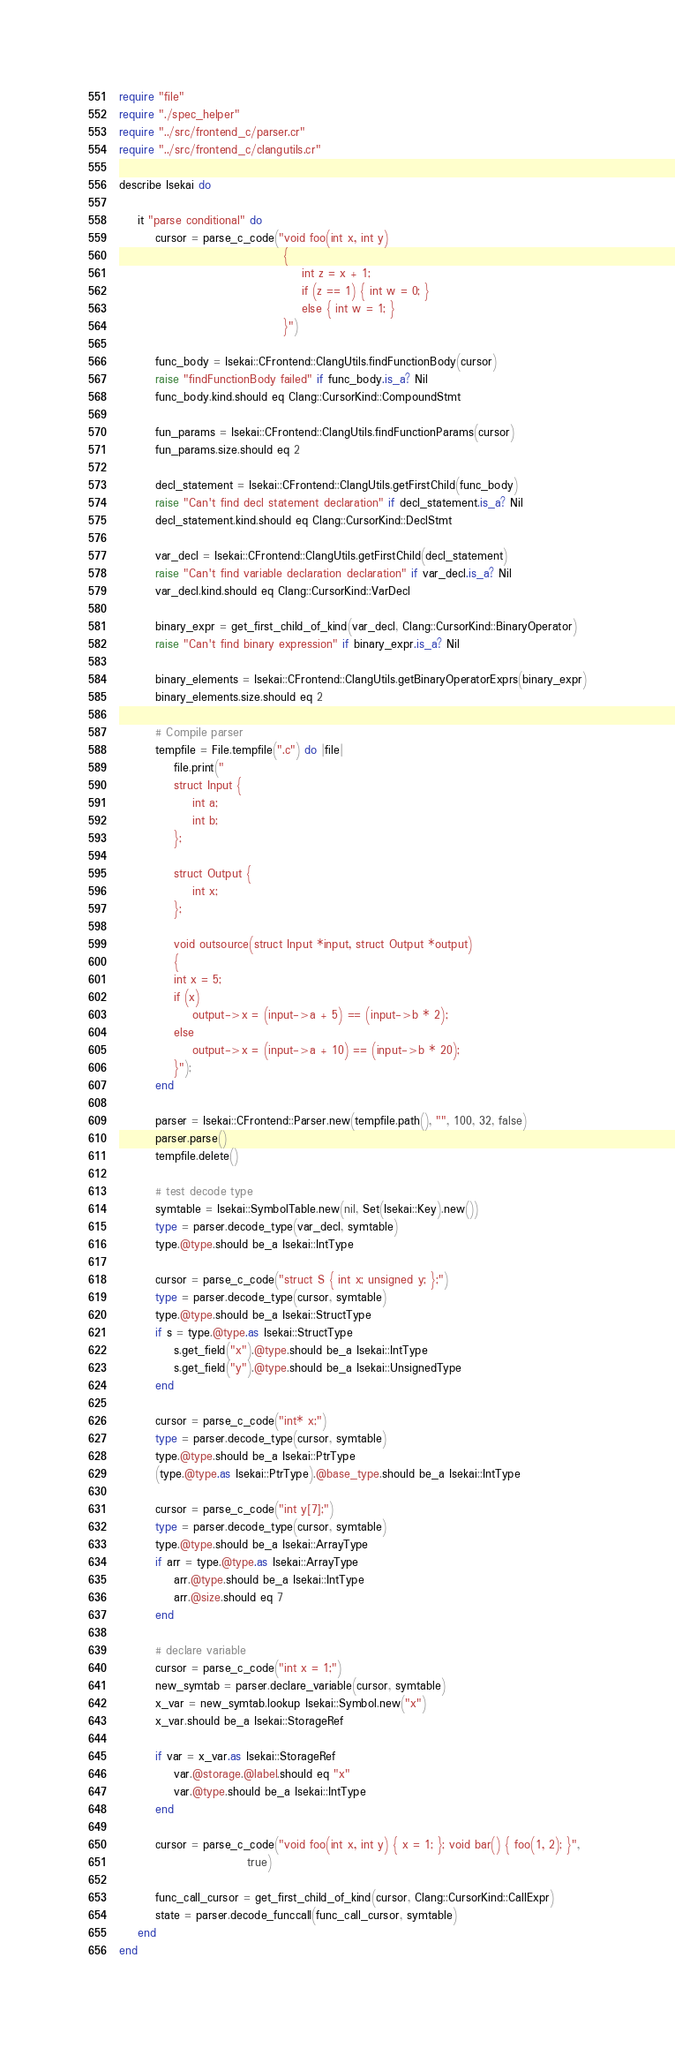Convert code to text. <code><loc_0><loc_0><loc_500><loc_500><_Crystal_>require "file"
require "./spec_helper"
require "../src/frontend_c/parser.cr"
require "../src/frontend_c/clangutils.cr"

describe Isekai do

    it "parse conditional" do
        cursor = parse_c_code("void foo(int x, int y)
                                    { 
                                        int z = x + 1; 
                                        if (z == 1) { int w = 0; }
                                        else { int w = 1; }
                                    }")

        func_body = Isekai::CFrontend::ClangUtils.findFunctionBody(cursor)
        raise "findFunctionBody failed" if func_body.is_a? Nil
        func_body.kind.should eq Clang::CursorKind::CompoundStmt

        fun_params = Isekai::CFrontend::ClangUtils.findFunctionParams(cursor)
        fun_params.size.should eq 2

        decl_statement = Isekai::CFrontend::ClangUtils.getFirstChild(func_body)
        raise "Can't find decl statement declaration" if decl_statement.is_a? Nil
        decl_statement.kind.should eq Clang::CursorKind::DeclStmt

        var_decl = Isekai::CFrontend::ClangUtils.getFirstChild(decl_statement)
        raise "Can't find variable declaration declaration" if var_decl.is_a? Nil
        var_decl.kind.should eq Clang::CursorKind::VarDecl

        binary_expr = get_first_child_of_kind(var_decl, Clang::CursorKind::BinaryOperator)
        raise "Can't find binary expression" if binary_expr.is_a? Nil

        binary_elements = Isekai::CFrontend::ClangUtils.getBinaryOperatorExprs(binary_expr)
        binary_elements.size.should eq 2

        # Compile parser
        tempfile = File.tempfile(".c") do |file|
            file.print("
            struct Input {
                int a;
                int b;
            };

            struct Output {
                int x;
            };

            void outsource(struct Input *input, struct Output *output)
            {
            int x = 5;
            if (x)
                output->x = (input->a + 5) == (input->b * 2);
            else
                output->x = (input->a + 10) == (input->b * 20);
            }");
        end

        parser = Isekai::CFrontend::Parser.new(tempfile.path(), "", 100, 32, false)
        parser.parse()
        tempfile.delete()

        # test decode type
        symtable = Isekai::SymbolTable.new(nil, Set(Isekai::Key).new())
        type = parser.decode_type(var_decl, symtable)
        type.@type.should be_a Isekai::IntType

        cursor = parse_c_code("struct S { int x; unsigned y; };")
        type = parser.decode_type(cursor, symtable)
        type.@type.should be_a Isekai::StructType
        if s = type.@type.as Isekai::StructType
            s.get_field("x").@type.should be_a Isekai::IntType
            s.get_field("y").@type.should be_a Isekai::UnsignedType
        end

        cursor = parse_c_code("int* x;")
        type = parser.decode_type(cursor, symtable)
        type.@type.should be_a Isekai::PtrType
        (type.@type.as Isekai::PtrType).@base_type.should be_a Isekai::IntType

        cursor = parse_c_code("int y[7];")
        type = parser.decode_type(cursor, symtable)
        type.@type.should be_a Isekai::ArrayType
        if arr = type.@type.as Isekai::ArrayType
            arr.@type.should be_a Isekai::IntType
            arr.@size.should eq 7
        end

        # declare variable
        cursor = parse_c_code("int x = 1;")
        new_symtab = parser.declare_variable(cursor, symtable)
        x_var = new_symtab.lookup Isekai::Symbol.new("x")
        x_var.should be_a Isekai::StorageRef

        if var = x_var.as Isekai::StorageRef
            var.@storage.@label.should eq "x"
            var.@type.should be_a Isekai::IntType
        end

        cursor = parse_c_code("void foo(int x, int y) { x = 1; }; void bar() { foo(1, 2); }",
                            true)

        func_call_cursor = get_first_child_of_kind(cursor, Clang::CursorKind::CallExpr)
        state = parser.decode_funccall(func_call_cursor, symtable)
    end
end
</code> 